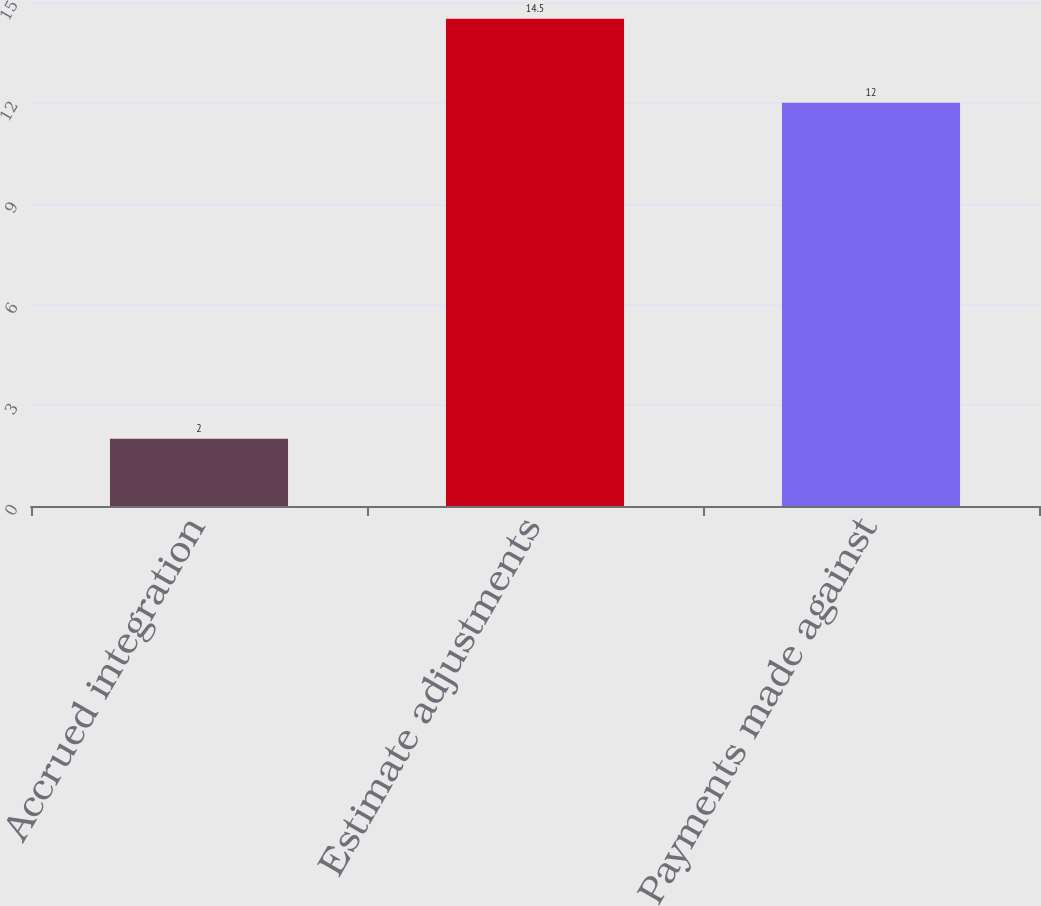Convert chart. <chart><loc_0><loc_0><loc_500><loc_500><bar_chart><fcel>Accrued integration<fcel>Estimate adjustments<fcel>Payments made against<nl><fcel>2<fcel>14.5<fcel>12<nl></chart> 